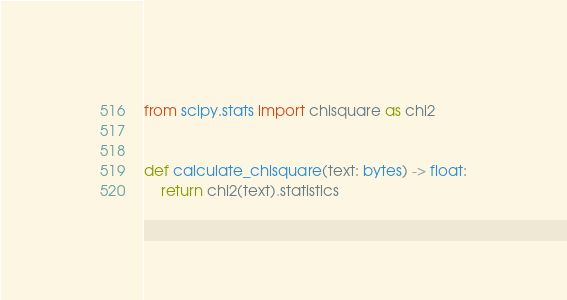Convert code to text. <code><loc_0><loc_0><loc_500><loc_500><_Python_>from scipy.stats import chisquare as chi2


def calculate_chisquare(text: bytes) -> float:
    return chi2(text).statistics
</code> 